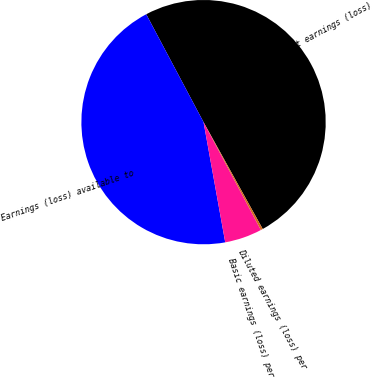<chart> <loc_0><loc_0><loc_500><loc_500><pie_chart><fcel>Net earnings (loss)<fcel>Earnings (loss) available to<fcel>Basic earnings (loss) per<fcel>Diluted earnings (loss) per<nl><fcel>49.72%<fcel>45.07%<fcel>4.93%<fcel>0.28%<nl></chart> 